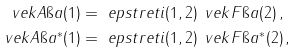Convert formula to latex. <formula><loc_0><loc_0><loc_500><loc_500>\ v e k A \i a ( 1 ) & = \ e p s t r e t i ( 1 , 2 ) \, \ v e k F \i a ( 2 ) \, , \\ \ v e k A \i a ^ { * } ( 1 ) & = \ e p s t r e t i ( 1 , 2 ) \, \ v e k F \i a ^ { * } ( 2 ) \, ,</formula> 